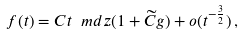<formula> <loc_0><loc_0><loc_500><loc_500>f ( t ) = C t ^ { \ } m d z ( 1 + \widetilde { C } g ) + o ( t ^ { - \frac { 3 } { 2 } } ) \, ,</formula> 